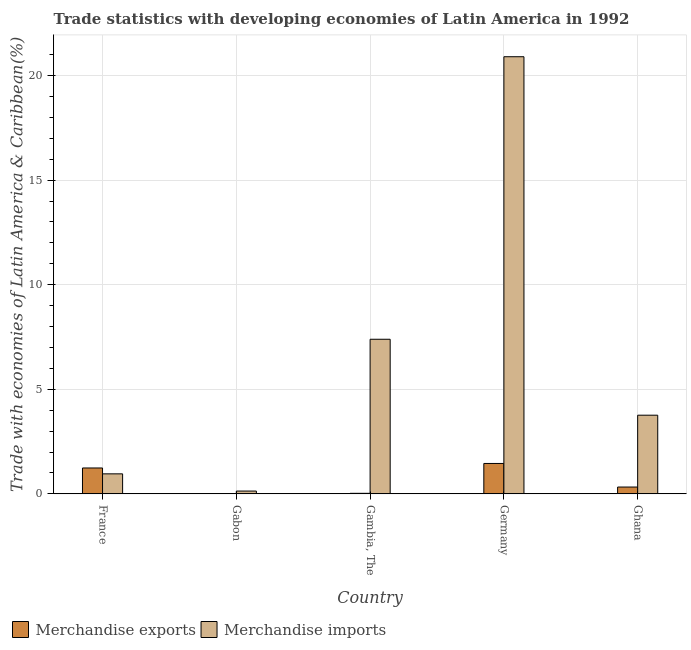How many different coloured bars are there?
Provide a short and direct response. 2. How many bars are there on the 3rd tick from the left?
Your response must be concise. 2. What is the label of the 3rd group of bars from the left?
Your answer should be very brief. Gambia, The. What is the merchandise imports in Germany?
Provide a short and direct response. 20.9. Across all countries, what is the maximum merchandise exports?
Keep it short and to the point. 1.45. Across all countries, what is the minimum merchandise exports?
Offer a terse response. 0. In which country was the merchandise imports maximum?
Ensure brevity in your answer.  Germany. In which country was the merchandise imports minimum?
Offer a terse response. Gabon. What is the total merchandise imports in the graph?
Your answer should be very brief. 33.15. What is the difference between the merchandise imports in France and that in Gabon?
Offer a terse response. 0.82. What is the difference between the merchandise imports in Gambia, The and the merchandise exports in France?
Ensure brevity in your answer.  6.15. What is the average merchandise exports per country?
Your answer should be very brief. 0.61. What is the difference between the merchandise imports and merchandise exports in France?
Ensure brevity in your answer.  -0.28. In how many countries, is the merchandise exports greater than 10 %?
Provide a short and direct response. 0. What is the ratio of the merchandise imports in France to that in Ghana?
Offer a very short reply. 0.25. Is the merchandise imports in Gabon less than that in Germany?
Ensure brevity in your answer.  Yes. What is the difference between the highest and the second highest merchandise exports?
Your response must be concise. 0.22. What is the difference between the highest and the lowest merchandise exports?
Make the answer very short. 1.45. Is the sum of the merchandise imports in France and Gabon greater than the maximum merchandise exports across all countries?
Provide a succinct answer. No. How many bars are there?
Provide a short and direct response. 10. Are all the bars in the graph horizontal?
Your response must be concise. No. How many countries are there in the graph?
Your answer should be compact. 5. What is the difference between two consecutive major ticks on the Y-axis?
Ensure brevity in your answer.  5. Does the graph contain grids?
Give a very brief answer. Yes. What is the title of the graph?
Keep it short and to the point. Trade statistics with developing economies of Latin America in 1992. Does "Death rate" appear as one of the legend labels in the graph?
Offer a terse response. No. What is the label or title of the Y-axis?
Give a very brief answer. Trade with economies of Latin America & Caribbean(%). What is the Trade with economies of Latin America & Caribbean(%) of Merchandise exports in France?
Keep it short and to the point. 1.24. What is the Trade with economies of Latin America & Caribbean(%) in Merchandise imports in France?
Your response must be concise. 0.96. What is the Trade with economies of Latin America & Caribbean(%) of Merchandise exports in Gabon?
Your answer should be compact. 0. What is the Trade with economies of Latin America & Caribbean(%) in Merchandise imports in Gabon?
Your answer should be very brief. 0.13. What is the Trade with economies of Latin America & Caribbean(%) in Merchandise exports in Gambia, The?
Keep it short and to the point. 0.03. What is the Trade with economies of Latin America & Caribbean(%) in Merchandise imports in Gambia, The?
Offer a terse response. 7.39. What is the Trade with economies of Latin America & Caribbean(%) of Merchandise exports in Germany?
Ensure brevity in your answer.  1.45. What is the Trade with economies of Latin America & Caribbean(%) in Merchandise imports in Germany?
Give a very brief answer. 20.9. What is the Trade with economies of Latin America & Caribbean(%) in Merchandise exports in Ghana?
Offer a very short reply. 0.33. What is the Trade with economies of Latin America & Caribbean(%) in Merchandise imports in Ghana?
Offer a very short reply. 3.76. Across all countries, what is the maximum Trade with economies of Latin America & Caribbean(%) of Merchandise exports?
Your answer should be compact. 1.45. Across all countries, what is the maximum Trade with economies of Latin America & Caribbean(%) in Merchandise imports?
Provide a short and direct response. 20.9. Across all countries, what is the minimum Trade with economies of Latin America & Caribbean(%) of Merchandise exports?
Ensure brevity in your answer.  0. Across all countries, what is the minimum Trade with economies of Latin America & Caribbean(%) of Merchandise imports?
Your answer should be compact. 0.13. What is the total Trade with economies of Latin America & Caribbean(%) of Merchandise exports in the graph?
Provide a short and direct response. 3.04. What is the total Trade with economies of Latin America & Caribbean(%) of Merchandise imports in the graph?
Offer a very short reply. 33.15. What is the difference between the Trade with economies of Latin America & Caribbean(%) of Merchandise exports in France and that in Gabon?
Keep it short and to the point. 1.24. What is the difference between the Trade with economies of Latin America & Caribbean(%) of Merchandise imports in France and that in Gabon?
Provide a succinct answer. 0.82. What is the difference between the Trade with economies of Latin America & Caribbean(%) in Merchandise exports in France and that in Gambia, The?
Give a very brief answer. 1.21. What is the difference between the Trade with economies of Latin America & Caribbean(%) in Merchandise imports in France and that in Gambia, The?
Provide a short and direct response. -6.44. What is the difference between the Trade with economies of Latin America & Caribbean(%) in Merchandise exports in France and that in Germany?
Your answer should be compact. -0.22. What is the difference between the Trade with economies of Latin America & Caribbean(%) of Merchandise imports in France and that in Germany?
Offer a very short reply. -19.95. What is the difference between the Trade with economies of Latin America & Caribbean(%) in Merchandise exports in France and that in Ghana?
Your answer should be very brief. 0.91. What is the difference between the Trade with economies of Latin America & Caribbean(%) of Merchandise imports in France and that in Ghana?
Your answer should be compact. -2.8. What is the difference between the Trade with economies of Latin America & Caribbean(%) in Merchandise exports in Gabon and that in Gambia, The?
Provide a short and direct response. -0.03. What is the difference between the Trade with economies of Latin America & Caribbean(%) of Merchandise imports in Gabon and that in Gambia, The?
Your response must be concise. -7.26. What is the difference between the Trade with economies of Latin America & Caribbean(%) of Merchandise exports in Gabon and that in Germany?
Give a very brief answer. -1.45. What is the difference between the Trade with economies of Latin America & Caribbean(%) in Merchandise imports in Gabon and that in Germany?
Keep it short and to the point. -20.77. What is the difference between the Trade with economies of Latin America & Caribbean(%) in Merchandise exports in Gabon and that in Ghana?
Your answer should be very brief. -0.33. What is the difference between the Trade with economies of Latin America & Caribbean(%) in Merchandise imports in Gabon and that in Ghana?
Offer a terse response. -3.63. What is the difference between the Trade with economies of Latin America & Caribbean(%) in Merchandise exports in Gambia, The and that in Germany?
Offer a terse response. -1.43. What is the difference between the Trade with economies of Latin America & Caribbean(%) in Merchandise imports in Gambia, The and that in Germany?
Keep it short and to the point. -13.51. What is the difference between the Trade with economies of Latin America & Caribbean(%) in Merchandise exports in Gambia, The and that in Ghana?
Ensure brevity in your answer.  -0.3. What is the difference between the Trade with economies of Latin America & Caribbean(%) of Merchandise imports in Gambia, The and that in Ghana?
Provide a succinct answer. 3.63. What is the difference between the Trade with economies of Latin America & Caribbean(%) in Merchandise exports in Germany and that in Ghana?
Make the answer very short. 1.13. What is the difference between the Trade with economies of Latin America & Caribbean(%) in Merchandise imports in Germany and that in Ghana?
Your answer should be compact. 17.14. What is the difference between the Trade with economies of Latin America & Caribbean(%) of Merchandise exports in France and the Trade with economies of Latin America & Caribbean(%) of Merchandise imports in Gabon?
Ensure brevity in your answer.  1.1. What is the difference between the Trade with economies of Latin America & Caribbean(%) of Merchandise exports in France and the Trade with economies of Latin America & Caribbean(%) of Merchandise imports in Gambia, The?
Provide a succinct answer. -6.15. What is the difference between the Trade with economies of Latin America & Caribbean(%) in Merchandise exports in France and the Trade with economies of Latin America & Caribbean(%) in Merchandise imports in Germany?
Ensure brevity in your answer.  -19.66. What is the difference between the Trade with economies of Latin America & Caribbean(%) in Merchandise exports in France and the Trade with economies of Latin America & Caribbean(%) in Merchandise imports in Ghana?
Give a very brief answer. -2.52. What is the difference between the Trade with economies of Latin America & Caribbean(%) in Merchandise exports in Gabon and the Trade with economies of Latin America & Caribbean(%) in Merchandise imports in Gambia, The?
Provide a succinct answer. -7.39. What is the difference between the Trade with economies of Latin America & Caribbean(%) of Merchandise exports in Gabon and the Trade with economies of Latin America & Caribbean(%) of Merchandise imports in Germany?
Offer a very short reply. -20.9. What is the difference between the Trade with economies of Latin America & Caribbean(%) of Merchandise exports in Gabon and the Trade with economies of Latin America & Caribbean(%) of Merchandise imports in Ghana?
Make the answer very short. -3.76. What is the difference between the Trade with economies of Latin America & Caribbean(%) of Merchandise exports in Gambia, The and the Trade with economies of Latin America & Caribbean(%) of Merchandise imports in Germany?
Make the answer very short. -20.88. What is the difference between the Trade with economies of Latin America & Caribbean(%) in Merchandise exports in Gambia, The and the Trade with economies of Latin America & Caribbean(%) in Merchandise imports in Ghana?
Make the answer very short. -3.74. What is the difference between the Trade with economies of Latin America & Caribbean(%) of Merchandise exports in Germany and the Trade with economies of Latin America & Caribbean(%) of Merchandise imports in Ghana?
Your answer should be very brief. -2.31. What is the average Trade with economies of Latin America & Caribbean(%) of Merchandise exports per country?
Keep it short and to the point. 0.61. What is the average Trade with economies of Latin America & Caribbean(%) of Merchandise imports per country?
Give a very brief answer. 6.63. What is the difference between the Trade with economies of Latin America & Caribbean(%) of Merchandise exports and Trade with economies of Latin America & Caribbean(%) of Merchandise imports in France?
Your answer should be very brief. 0.28. What is the difference between the Trade with economies of Latin America & Caribbean(%) in Merchandise exports and Trade with economies of Latin America & Caribbean(%) in Merchandise imports in Gabon?
Make the answer very short. -0.13. What is the difference between the Trade with economies of Latin America & Caribbean(%) in Merchandise exports and Trade with economies of Latin America & Caribbean(%) in Merchandise imports in Gambia, The?
Keep it short and to the point. -7.37. What is the difference between the Trade with economies of Latin America & Caribbean(%) of Merchandise exports and Trade with economies of Latin America & Caribbean(%) of Merchandise imports in Germany?
Your answer should be very brief. -19.45. What is the difference between the Trade with economies of Latin America & Caribbean(%) in Merchandise exports and Trade with economies of Latin America & Caribbean(%) in Merchandise imports in Ghana?
Offer a terse response. -3.44. What is the ratio of the Trade with economies of Latin America & Caribbean(%) of Merchandise exports in France to that in Gabon?
Offer a terse response. 4605.93. What is the ratio of the Trade with economies of Latin America & Caribbean(%) of Merchandise imports in France to that in Gabon?
Offer a terse response. 7.13. What is the ratio of the Trade with economies of Latin America & Caribbean(%) of Merchandise exports in France to that in Gambia, The?
Your answer should be very brief. 47.89. What is the ratio of the Trade with economies of Latin America & Caribbean(%) of Merchandise imports in France to that in Gambia, The?
Provide a short and direct response. 0.13. What is the ratio of the Trade with economies of Latin America & Caribbean(%) in Merchandise exports in France to that in Germany?
Offer a terse response. 0.85. What is the ratio of the Trade with economies of Latin America & Caribbean(%) of Merchandise imports in France to that in Germany?
Your answer should be very brief. 0.05. What is the ratio of the Trade with economies of Latin America & Caribbean(%) of Merchandise exports in France to that in Ghana?
Your response must be concise. 3.79. What is the ratio of the Trade with economies of Latin America & Caribbean(%) of Merchandise imports in France to that in Ghana?
Provide a short and direct response. 0.25. What is the ratio of the Trade with economies of Latin America & Caribbean(%) of Merchandise exports in Gabon to that in Gambia, The?
Provide a short and direct response. 0.01. What is the ratio of the Trade with economies of Latin America & Caribbean(%) of Merchandise imports in Gabon to that in Gambia, The?
Keep it short and to the point. 0.02. What is the ratio of the Trade with economies of Latin America & Caribbean(%) in Merchandise imports in Gabon to that in Germany?
Offer a very short reply. 0.01. What is the ratio of the Trade with economies of Latin America & Caribbean(%) of Merchandise exports in Gabon to that in Ghana?
Your answer should be very brief. 0. What is the ratio of the Trade with economies of Latin America & Caribbean(%) in Merchandise imports in Gabon to that in Ghana?
Ensure brevity in your answer.  0.04. What is the ratio of the Trade with economies of Latin America & Caribbean(%) of Merchandise exports in Gambia, The to that in Germany?
Offer a very short reply. 0.02. What is the ratio of the Trade with economies of Latin America & Caribbean(%) in Merchandise imports in Gambia, The to that in Germany?
Make the answer very short. 0.35. What is the ratio of the Trade with economies of Latin America & Caribbean(%) of Merchandise exports in Gambia, The to that in Ghana?
Offer a very short reply. 0.08. What is the ratio of the Trade with economies of Latin America & Caribbean(%) of Merchandise imports in Gambia, The to that in Ghana?
Your response must be concise. 1.97. What is the ratio of the Trade with economies of Latin America & Caribbean(%) of Merchandise exports in Germany to that in Ghana?
Your answer should be compact. 4.45. What is the ratio of the Trade with economies of Latin America & Caribbean(%) of Merchandise imports in Germany to that in Ghana?
Give a very brief answer. 5.56. What is the difference between the highest and the second highest Trade with economies of Latin America & Caribbean(%) of Merchandise exports?
Offer a very short reply. 0.22. What is the difference between the highest and the second highest Trade with economies of Latin America & Caribbean(%) in Merchandise imports?
Offer a very short reply. 13.51. What is the difference between the highest and the lowest Trade with economies of Latin America & Caribbean(%) of Merchandise exports?
Provide a short and direct response. 1.45. What is the difference between the highest and the lowest Trade with economies of Latin America & Caribbean(%) of Merchandise imports?
Your answer should be compact. 20.77. 